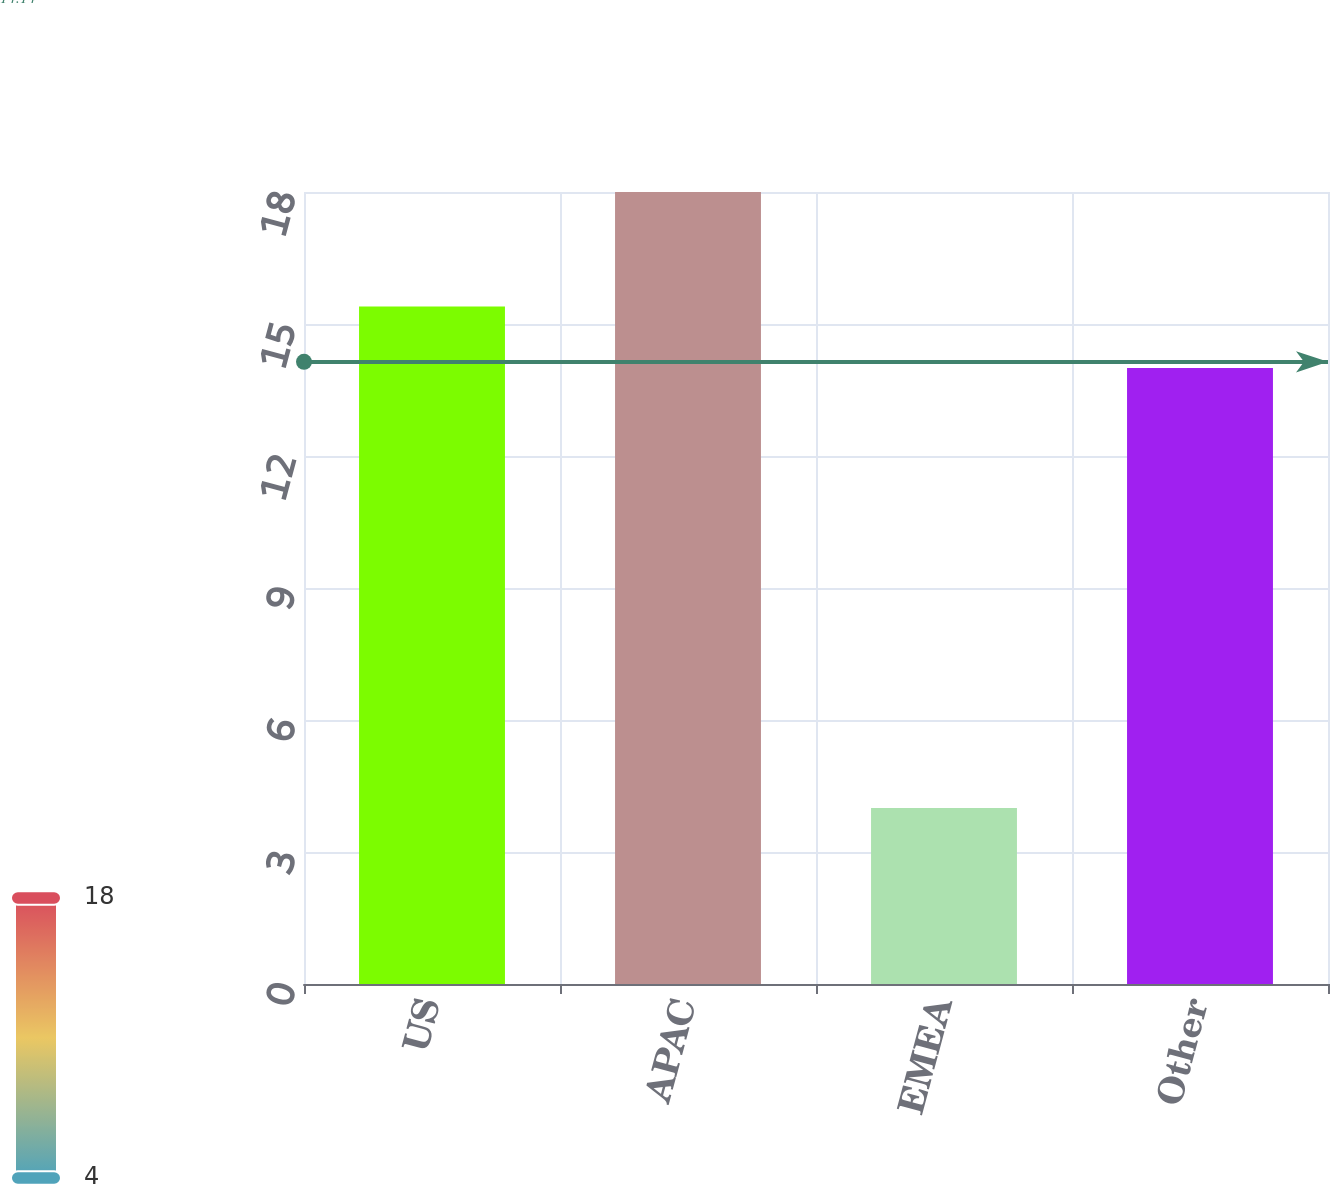Convert chart. <chart><loc_0><loc_0><loc_500><loc_500><bar_chart><fcel>US<fcel>APAC<fcel>EMEA<fcel>Other<nl><fcel>15.4<fcel>18<fcel>4<fcel>14<nl></chart> 